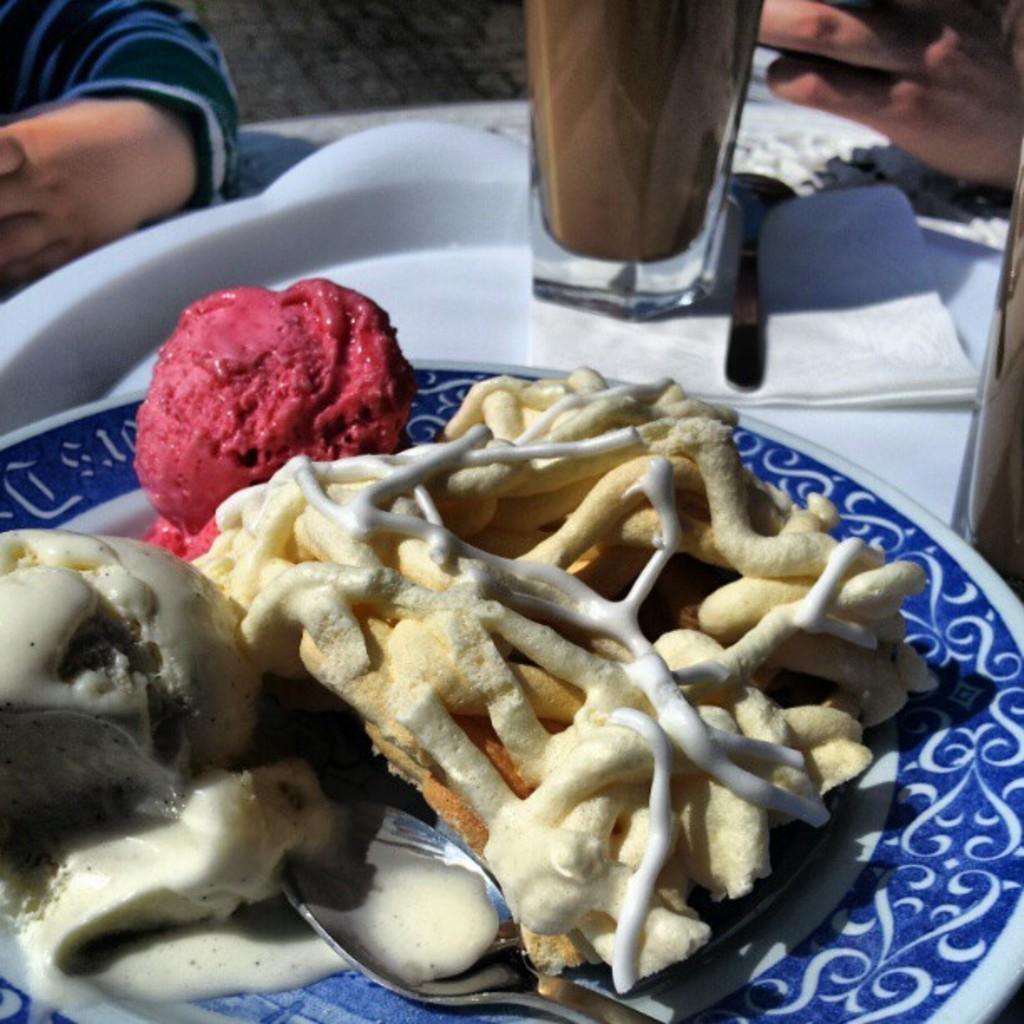Could you give a brief overview of what you see in this image? On this table there is a spoon, tissue paper, glass, plate, ice-cream and food. Here we can see people hands. 